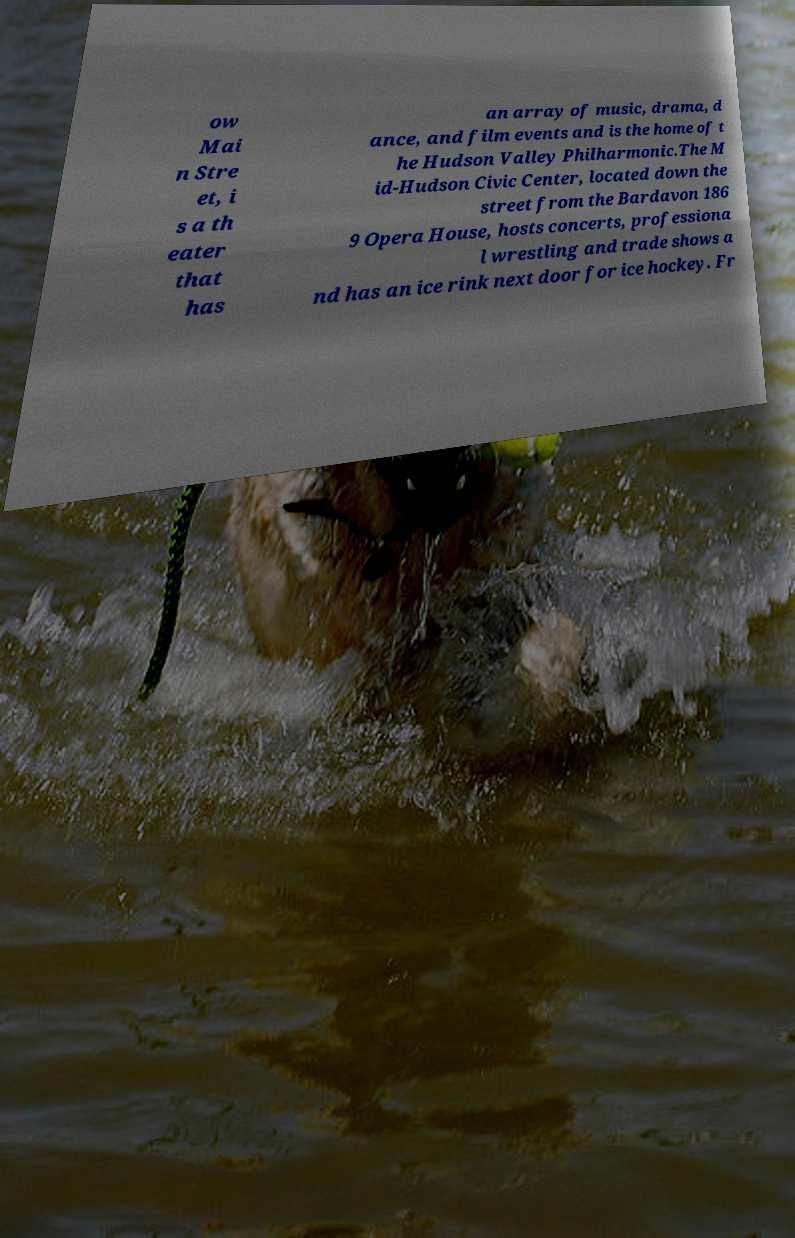There's text embedded in this image that I need extracted. Can you transcribe it verbatim? ow Mai n Stre et, i s a th eater that has an array of music, drama, d ance, and film events and is the home of t he Hudson Valley Philharmonic.The M id-Hudson Civic Center, located down the street from the Bardavon 186 9 Opera House, hosts concerts, professiona l wrestling and trade shows a nd has an ice rink next door for ice hockey. Fr 